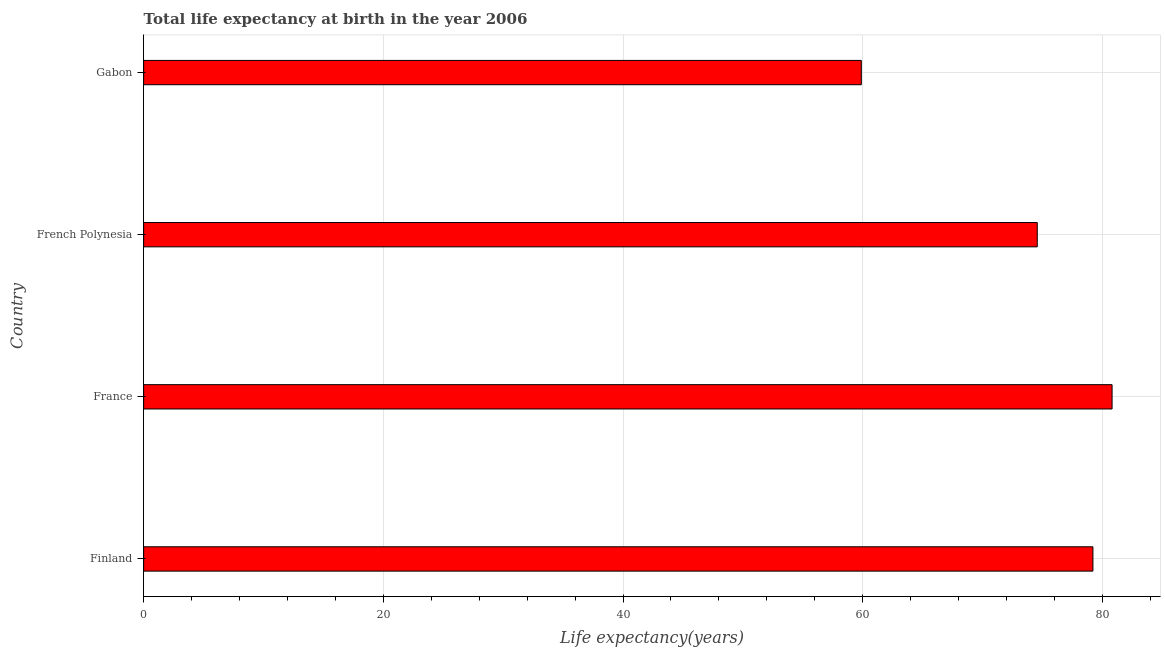Does the graph contain any zero values?
Your answer should be compact. No. Does the graph contain grids?
Keep it short and to the point. Yes. What is the title of the graph?
Ensure brevity in your answer.  Total life expectancy at birth in the year 2006. What is the label or title of the X-axis?
Your answer should be very brief. Life expectancy(years). What is the label or title of the Y-axis?
Ensure brevity in your answer.  Country. What is the life expectancy at birth in Finland?
Ensure brevity in your answer.  79.21. Across all countries, what is the maximum life expectancy at birth?
Give a very brief answer. 80.81. Across all countries, what is the minimum life expectancy at birth?
Offer a very short reply. 59.89. In which country was the life expectancy at birth maximum?
Give a very brief answer. France. In which country was the life expectancy at birth minimum?
Your response must be concise. Gabon. What is the sum of the life expectancy at birth?
Your response must be concise. 294.48. What is the difference between the life expectancy at birth in France and French Polynesia?
Provide a short and direct response. 6.24. What is the average life expectancy at birth per country?
Your response must be concise. 73.62. What is the median life expectancy at birth?
Ensure brevity in your answer.  76.89. What is the ratio of the life expectancy at birth in France to that in Gabon?
Your response must be concise. 1.35. What is the difference between the highest and the second highest life expectancy at birth?
Your answer should be very brief. 1.6. What is the difference between the highest and the lowest life expectancy at birth?
Offer a very short reply. 20.93. Are all the bars in the graph horizontal?
Offer a terse response. Yes. How many countries are there in the graph?
Provide a short and direct response. 4. Are the values on the major ticks of X-axis written in scientific E-notation?
Your response must be concise. No. What is the Life expectancy(years) in Finland?
Provide a succinct answer. 79.21. What is the Life expectancy(years) of France?
Your answer should be very brief. 80.81. What is the Life expectancy(years) of French Polynesia?
Ensure brevity in your answer.  74.57. What is the Life expectancy(years) in Gabon?
Your answer should be compact. 59.89. What is the difference between the Life expectancy(years) in Finland and France?
Your answer should be compact. -1.6. What is the difference between the Life expectancy(years) in Finland and French Polynesia?
Provide a succinct answer. 4.64. What is the difference between the Life expectancy(years) in Finland and Gabon?
Offer a very short reply. 19.33. What is the difference between the Life expectancy(years) in France and French Polynesia?
Offer a very short reply. 6.24. What is the difference between the Life expectancy(years) in France and Gabon?
Make the answer very short. 20.93. What is the difference between the Life expectancy(years) in French Polynesia and Gabon?
Your answer should be very brief. 14.68. What is the ratio of the Life expectancy(years) in Finland to that in French Polynesia?
Ensure brevity in your answer.  1.06. What is the ratio of the Life expectancy(years) in Finland to that in Gabon?
Make the answer very short. 1.32. What is the ratio of the Life expectancy(years) in France to that in French Polynesia?
Keep it short and to the point. 1.08. What is the ratio of the Life expectancy(years) in France to that in Gabon?
Keep it short and to the point. 1.35. What is the ratio of the Life expectancy(years) in French Polynesia to that in Gabon?
Offer a very short reply. 1.25. 